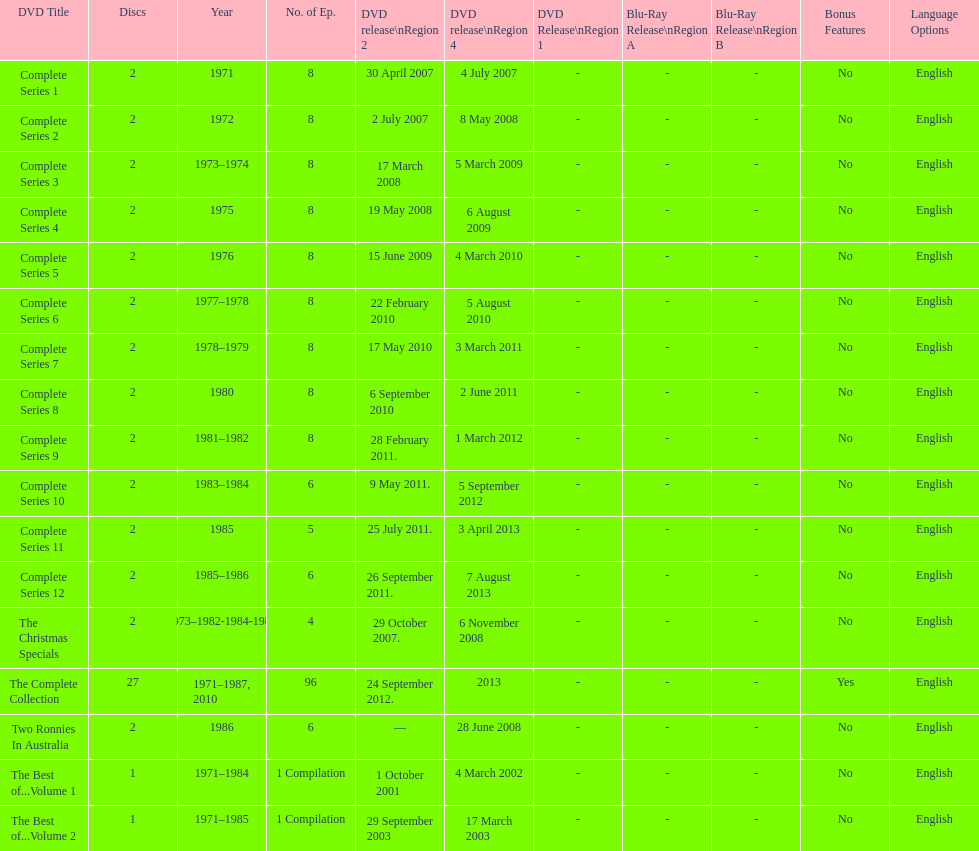How many "best of" volumes compile the top episodes of the television show "the two ronnies". 2. 